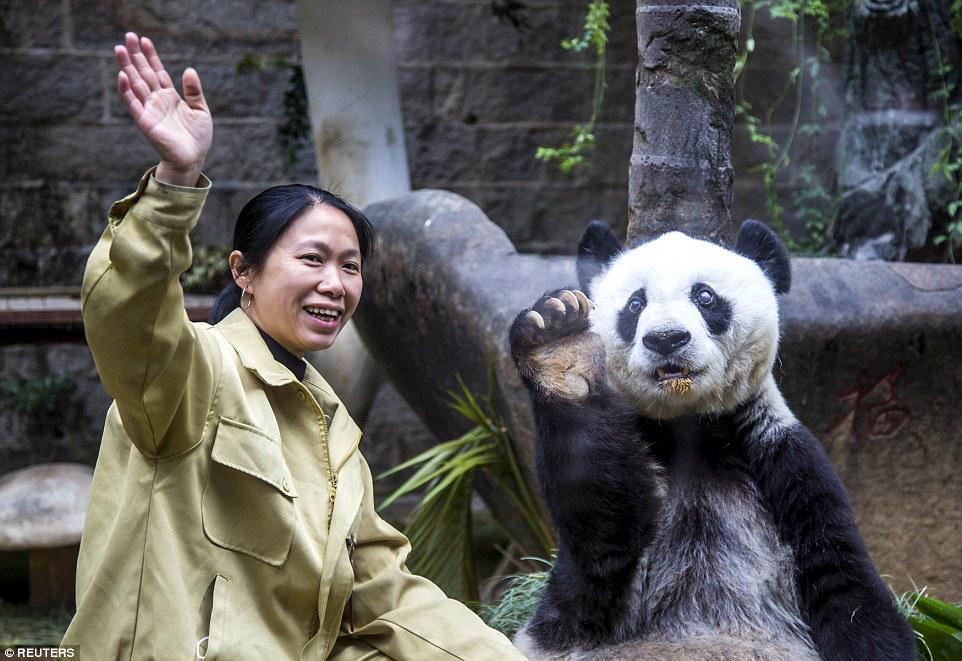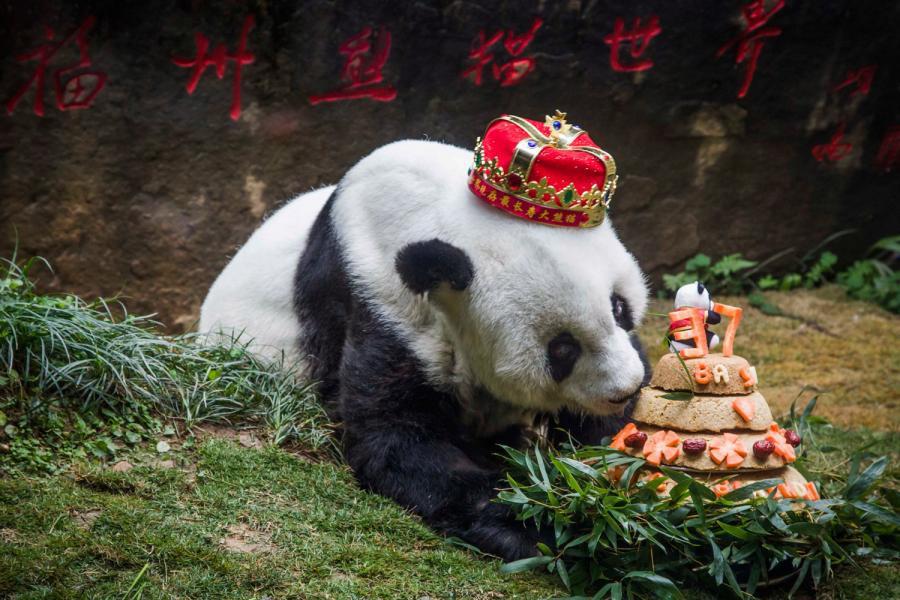The first image is the image on the left, the second image is the image on the right. Examine the images to the left and right. Is the description "The panda in the image on the right is wearing a hat." accurate? Answer yes or no. Yes. The first image is the image on the left, the second image is the image on the right. Evaluate the accuracy of this statement regarding the images: "The combined images include a dark-haired woman and a panda wearing a red-and-gold crown.". Is it true? Answer yes or no. Yes. 